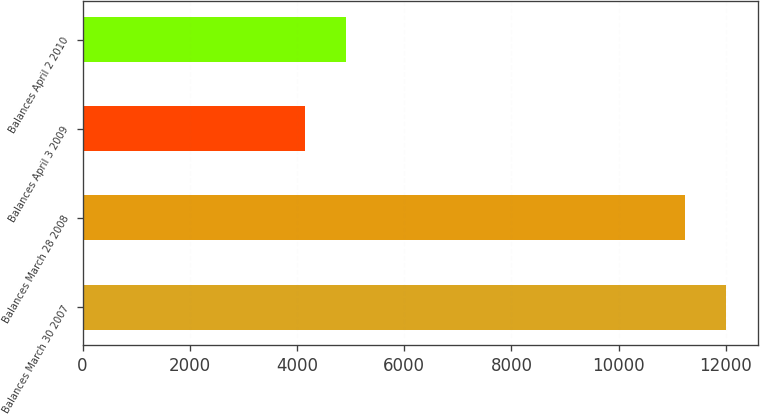Convert chart. <chart><loc_0><loc_0><loc_500><loc_500><bar_chart><fcel>Balances March 30 2007<fcel>Balances March 28 2008<fcel>Balances April 3 2009<fcel>Balances April 2 2010<nl><fcel>12005.4<fcel>11229<fcel>4147<fcel>4923.4<nl></chart> 